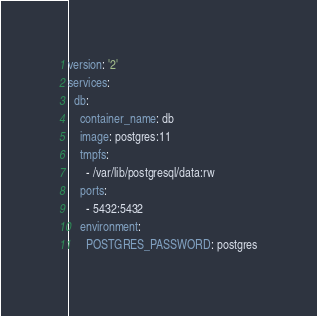<code> <loc_0><loc_0><loc_500><loc_500><_YAML_>version: '2'
services:
  db:
    container_name: db
    image: postgres:11
    tmpfs:
      - /var/lib/postgresql/data:rw
    ports:
      - 5432:5432
    environment:
      POSTGRES_PASSWORD: postgres</code> 